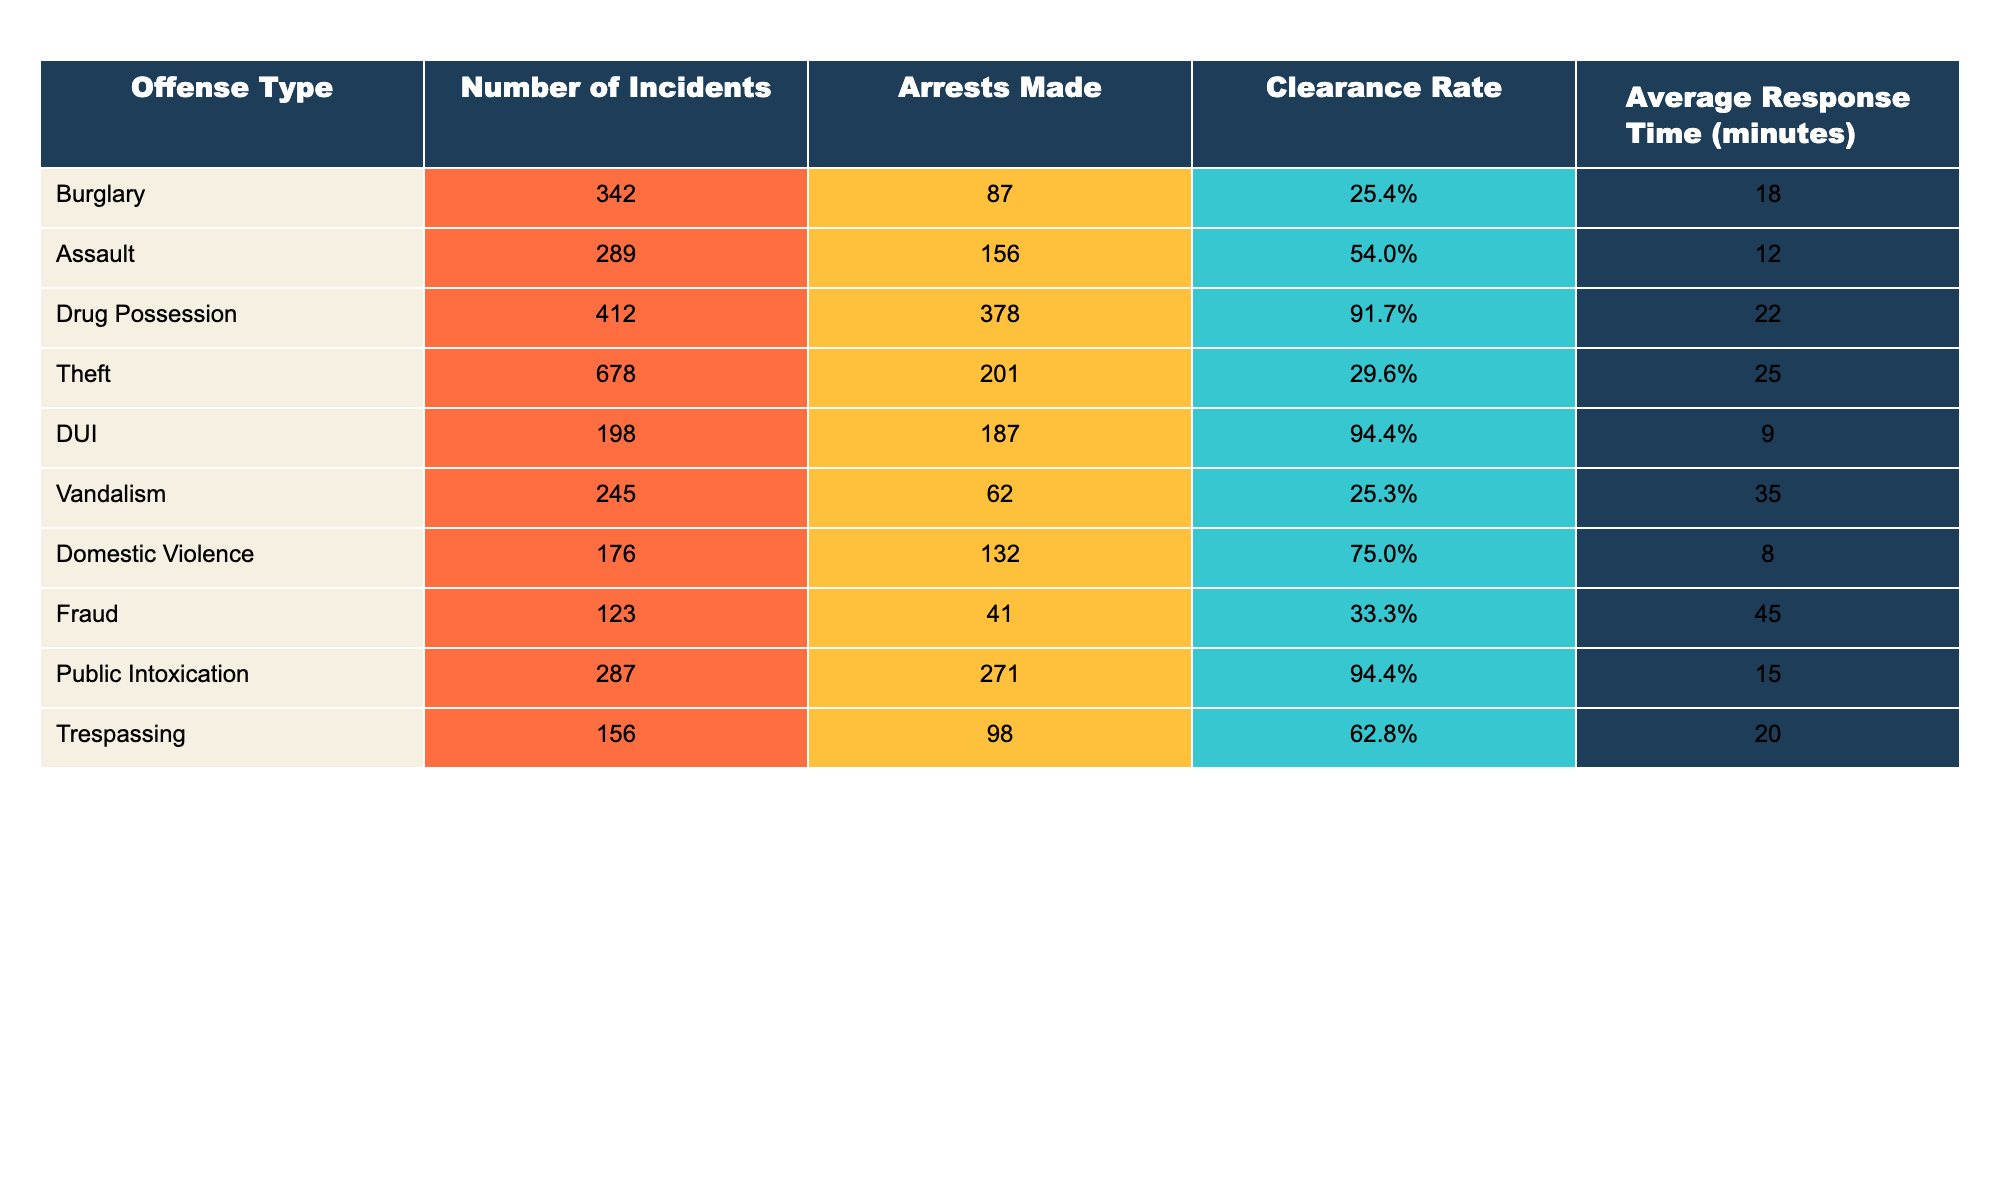What is the number of incidents for drug possession? The table lists 'Drug Possession' under the 'Offense Type' column, showing that there are 412 incidents listed next to it.
Answer: 412 What is the clearance rate for theft? The clearance rate is shown in the column corresponding to 'Theft', which indicates a clearance rate of 29.6%.
Answer: 29.6% How many arrests were made for assault? Referring to the table, under 'Assault', the column indicates that there were 156 arrests made.
Answer: 156 Which offense type has the highest number of incidents? Looking at the 'Number of Incidents' column, 'Theft' has the highest value at 678 incidents compared to others.
Answer: Theft What is the average response time for burglary? The table specifies that the average response time for 'Burglary' is listed as 18 minutes.
Answer: 18 minutes What is the difference in the number of incidents between drug possession and DUI? The number of incidents for drug possession is 412 and for DUI it is 198. The difference is 412 - 198 = 214.
Answer: 214 Is the clearance rate for vandalism higher than for burglary? The clearance rate for vandalism is 25.3% while for burglary it is 25.4%. Since 25.3% is less than 25.4%, the statement is false.
Answer: No What is the average clearance rate across all offenses? We sum all the clearance rates (25.4% + 54.0% + 91.7% + 29.6% + 94.4% + 25.3% + 75.0% + 33.3% + 94.4% + 62.8%) =  586.5%, then divide by 10 to get the average: 586.5% / 10 = 58.65%.
Answer: 58.65% How many arrests were made in total for drug possession, DUI, and domestic violence combined? Adding arrests for these offenses: 378 (drug possession) + 187 (DUI) + 132 (domestic violence) gives a total of 378 + 187 + 132 = 697 arrests.
Answer: 697 What offense type has the lowest clearance rate? Comparing the clearance rates, 'Theft' has the lowest at 29.6%, which is lower than all other offense types listed.
Answer: Theft 